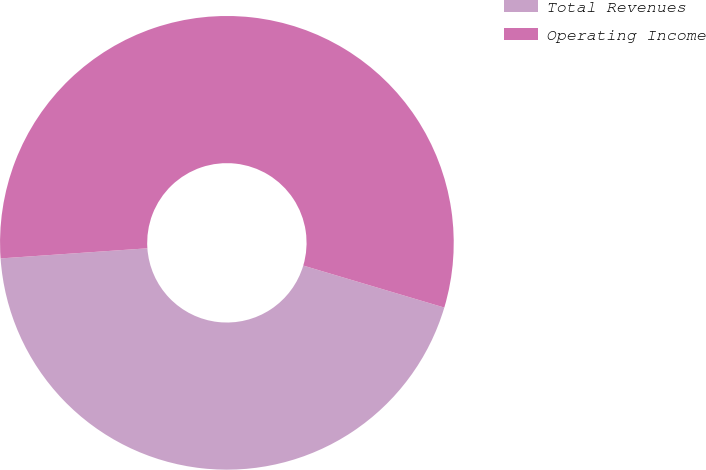Convert chart. <chart><loc_0><loc_0><loc_500><loc_500><pie_chart><fcel>Total Revenues<fcel>Operating Income<nl><fcel>44.3%<fcel>55.7%<nl></chart> 